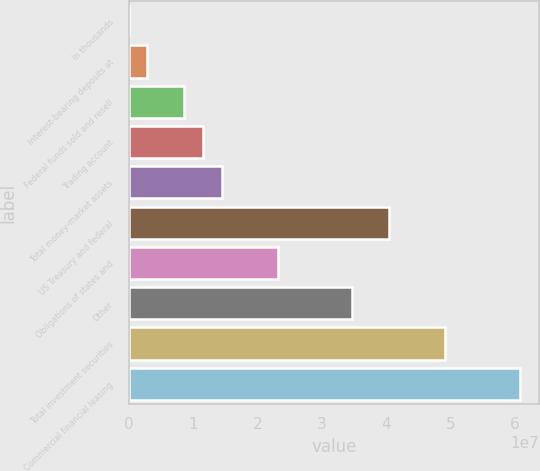Convert chart to OTSL. <chart><loc_0><loc_0><loc_500><loc_500><bar_chart><fcel>In thousands<fcel>Interest-bearing deposits at<fcel>Federal funds sold and resell<fcel>Trading account<fcel>Total money-market assets<fcel>US Treasury and federal<fcel>Obligations of states and<fcel>Other<fcel>Total investment securities<fcel>Commercial financial leasing<nl><fcel>2000<fcel>2.89675e+06<fcel>8.68624e+06<fcel>1.1581e+07<fcel>1.44757e+07<fcel>4.05284e+07<fcel>2.316e+07<fcel>3.47389e+07<fcel>4.92127e+07<fcel>6.07917e+07<nl></chart> 